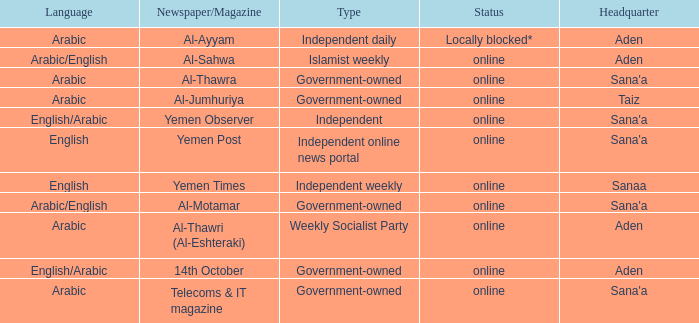What is Status, when Newspaper/Magazine is Al-Thawra? Online. 